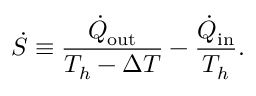Convert formula to latex. <formula><loc_0><loc_0><loc_500><loc_500>\dot { S } \equiv \frac { \dot { Q } _ { o u t } } { T _ { h } - \Delta T } - \frac { \dot { Q } _ { i n } } { T _ { h } } .</formula> 